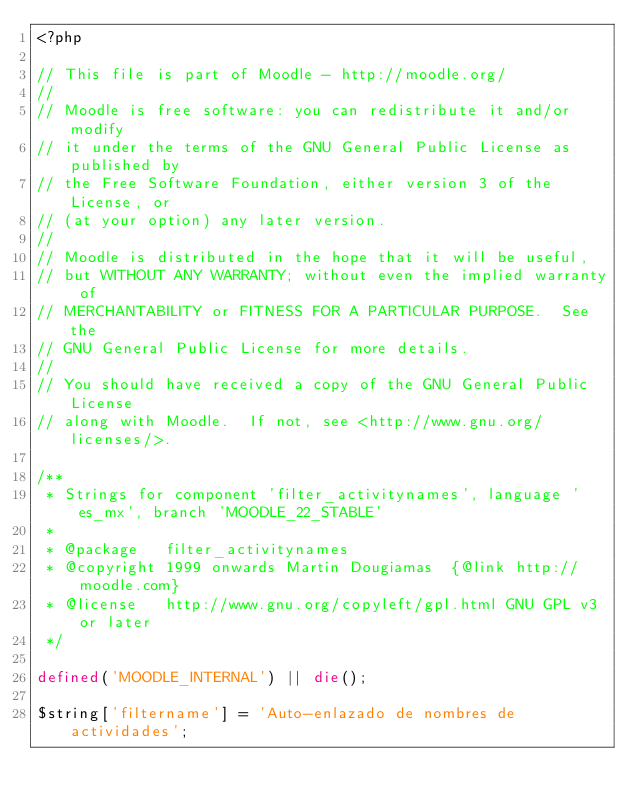Convert code to text. <code><loc_0><loc_0><loc_500><loc_500><_PHP_><?php

// This file is part of Moodle - http://moodle.org/
//
// Moodle is free software: you can redistribute it and/or modify
// it under the terms of the GNU General Public License as published by
// the Free Software Foundation, either version 3 of the License, or
// (at your option) any later version.
//
// Moodle is distributed in the hope that it will be useful,
// but WITHOUT ANY WARRANTY; without even the implied warranty of
// MERCHANTABILITY or FITNESS FOR A PARTICULAR PURPOSE.  See the
// GNU General Public License for more details.
//
// You should have received a copy of the GNU General Public License
// along with Moodle.  If not, see <http://www.gnu.org/licenses/>.

/**
 * Strings for component 'filter_activitynames', language 'es_mx', branch 'MOODLE_22_STABLE'
 *
 * @package   filter_activitynames
 * @copyright 1999 onwards Martin Dougiamas  {@link http://moodle.com}
 * @license   http://www.gnu.org/copyleft/gpl.html GNU GPL v3 or later
 */

defined('MOODLE_INTERNAL') || die();

$string['filtername'] = 'Auto-enlazado de nombres de actividades';
</code> 